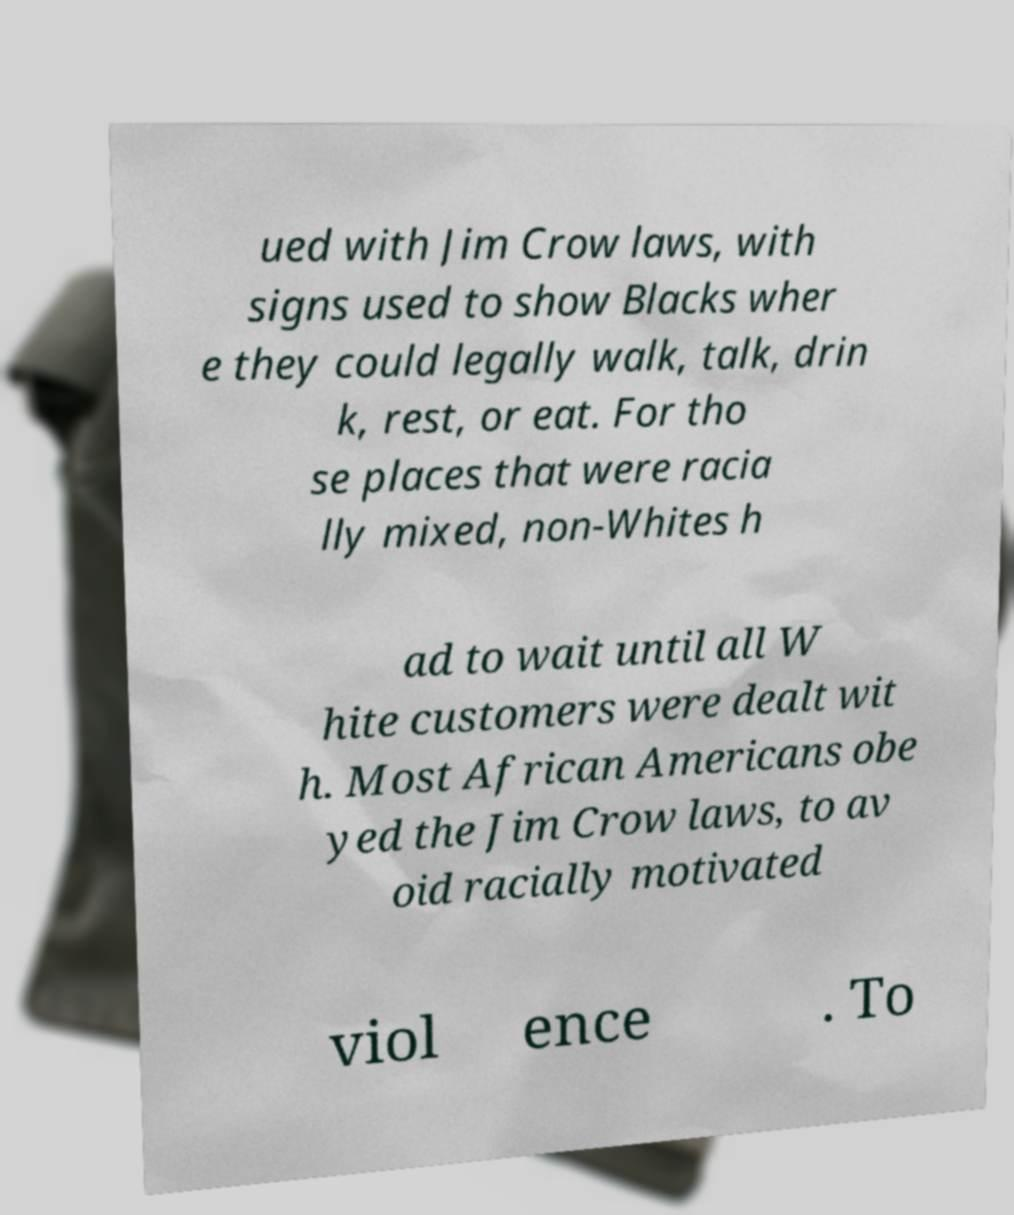I need the written content from this picture converted into text. Can you do that? ued with Jim Crow laws, with signs used to show Blacks wher e they could legally walk, talk, drin k, rest, or eat. For tho se places that were racia lly mixed, non-Whites h ad to wait until all W hite customers were dealt wit h. Most African Americans obe yed the Jim Crow laws, to av oid racially motivated viol ence . To 